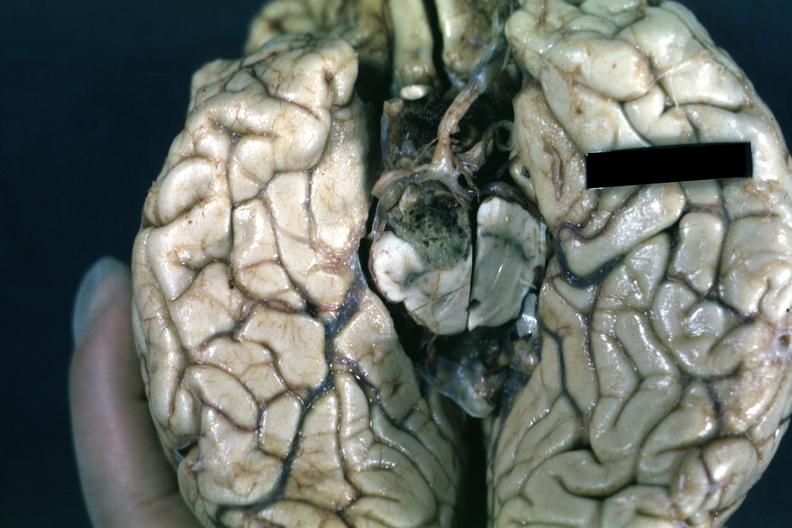where does this belong to?
Answer the question using a single word or phrase. Endocrine system 